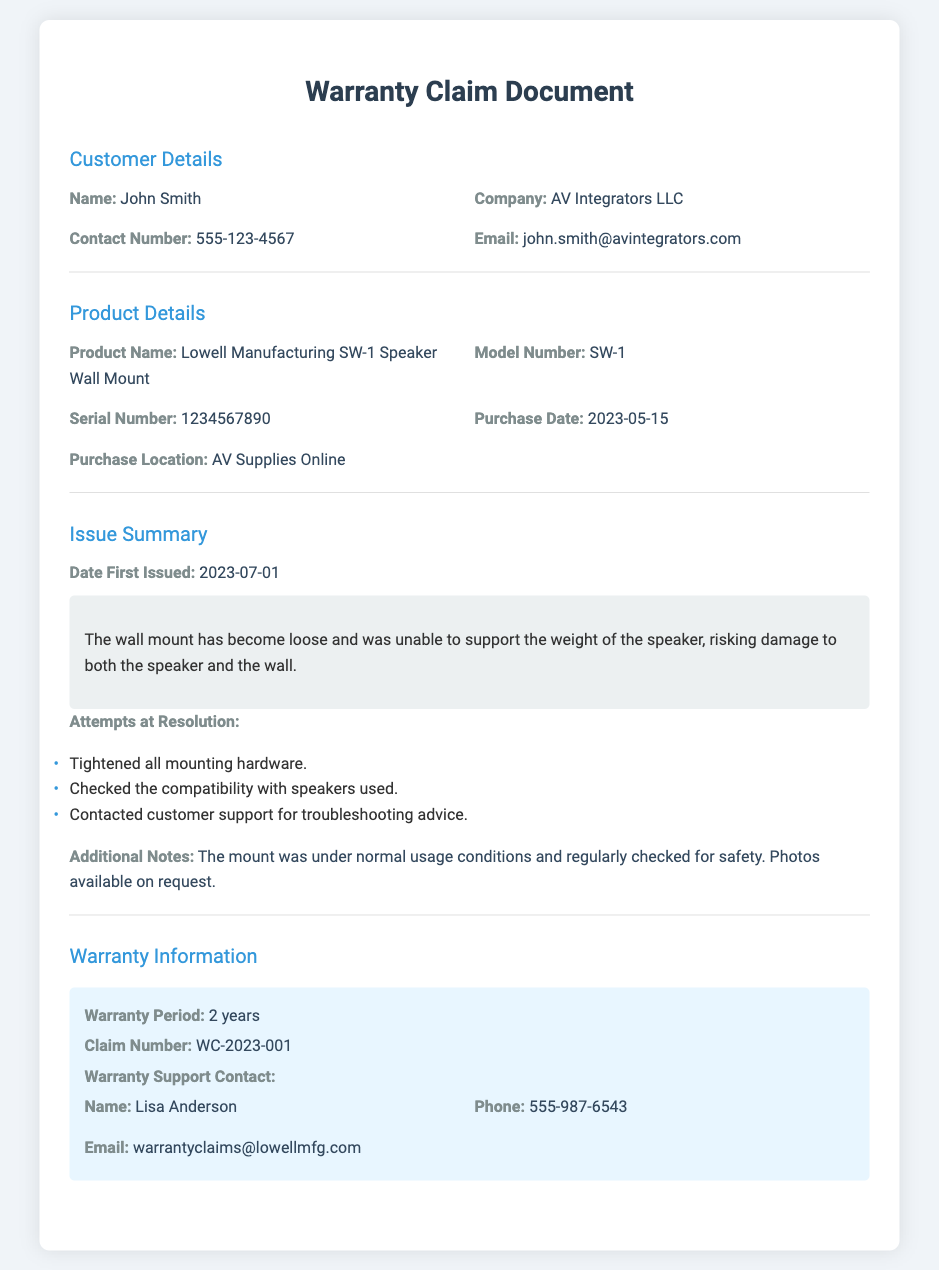What is the name of the customer? The customer's name is explicitly mentioned in the document as John Smith.
Answer: John Smith What is the product name? The product name is specified in the document under Product Details as Lowell Manufacturing SW-1 Speaker Wall Mount.
Answer: Lowell Manufacturing SW-1 Speaker Wall Mount When was the product purchased? The purchase date is listed in the document and it is 2023-05-15.
Answer: 2023-05-15 What is the serial number of the product? The serial number can be found in the Product Details section as 1234567890.
Answer: 1234567890 What issue was reported with the wall mount? The document states that the wall mount has become loose and was unable to support the weight of the speaker.
Answer: Loose and unable to support weight How many attempts at resolution were made? The document lists three attempts at resolution.
Answer: Three Who is the warranty support contact? The warranty support contact is listed as Lisa Anderson in the Warranty Information section.
Answer: Lisa Anderson What is the warranty period for the product? The warranty period is mentioned in the document as 2 years.
Answer: 2 years What is the claim number associated with this warranty claim? The document specifies the claim number as WC-2023-001.
Answer: WC-2023-001 